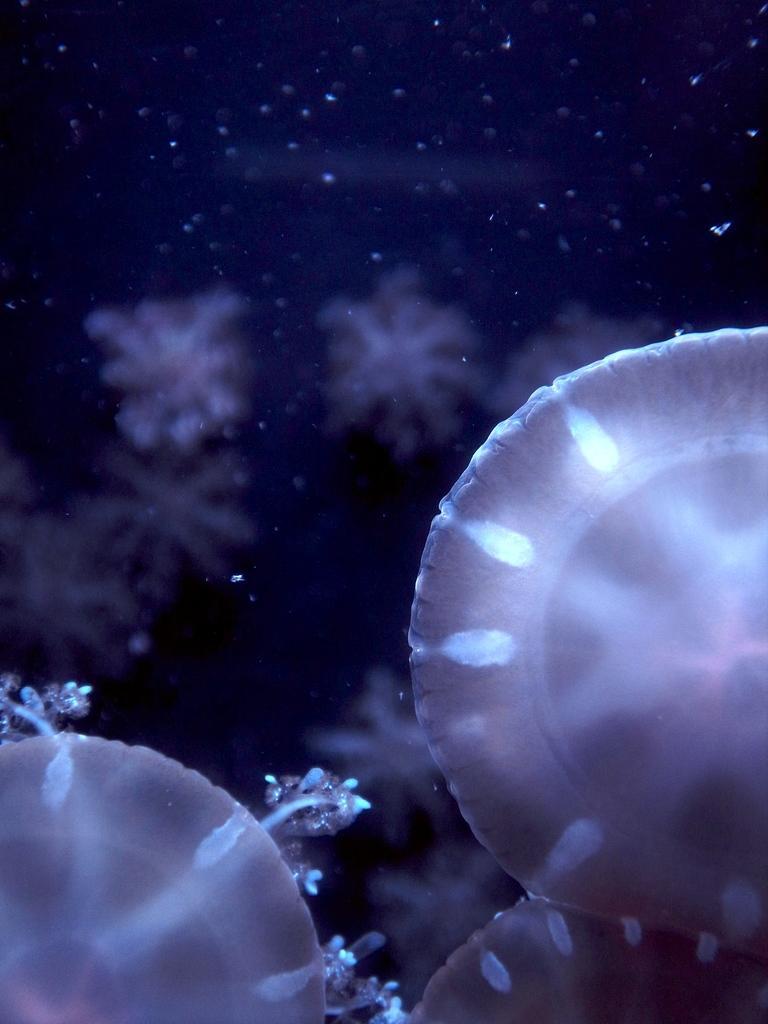How would you summarize this image in a sentence or two? In the picture we can see some jelly fishes in the water. 